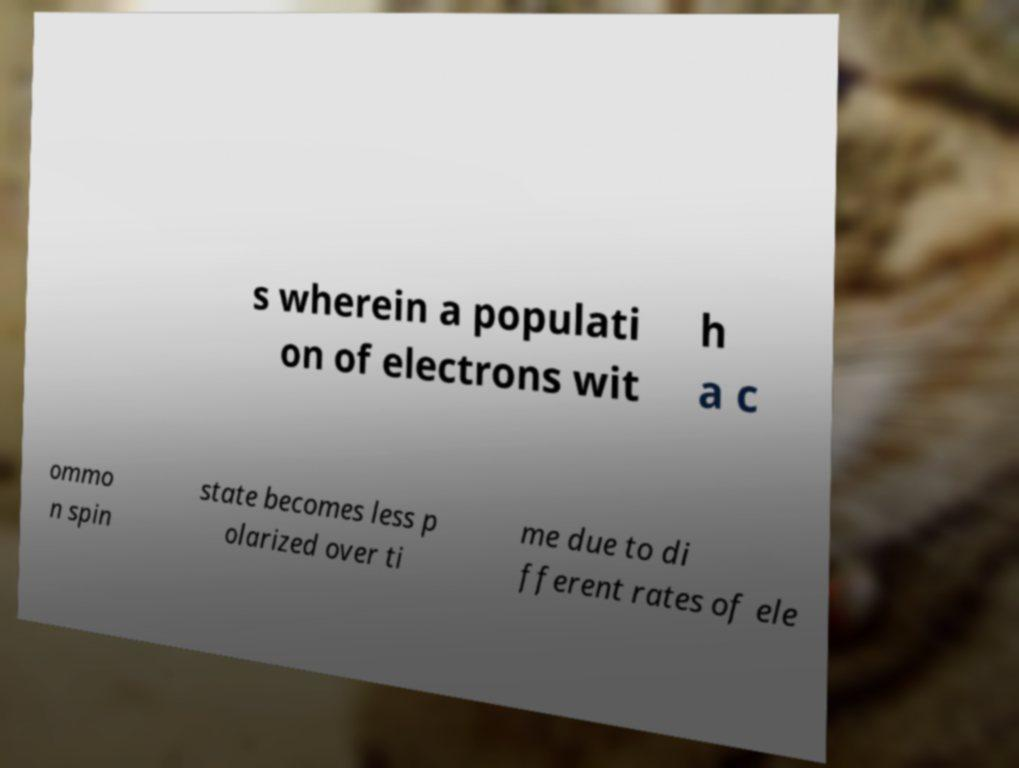Could you extract and type out the text from this image? s wherein a populati on of electrons wit h a c ommo n spin state becomes less p olarized over ti me due to di fferent rates of ele 